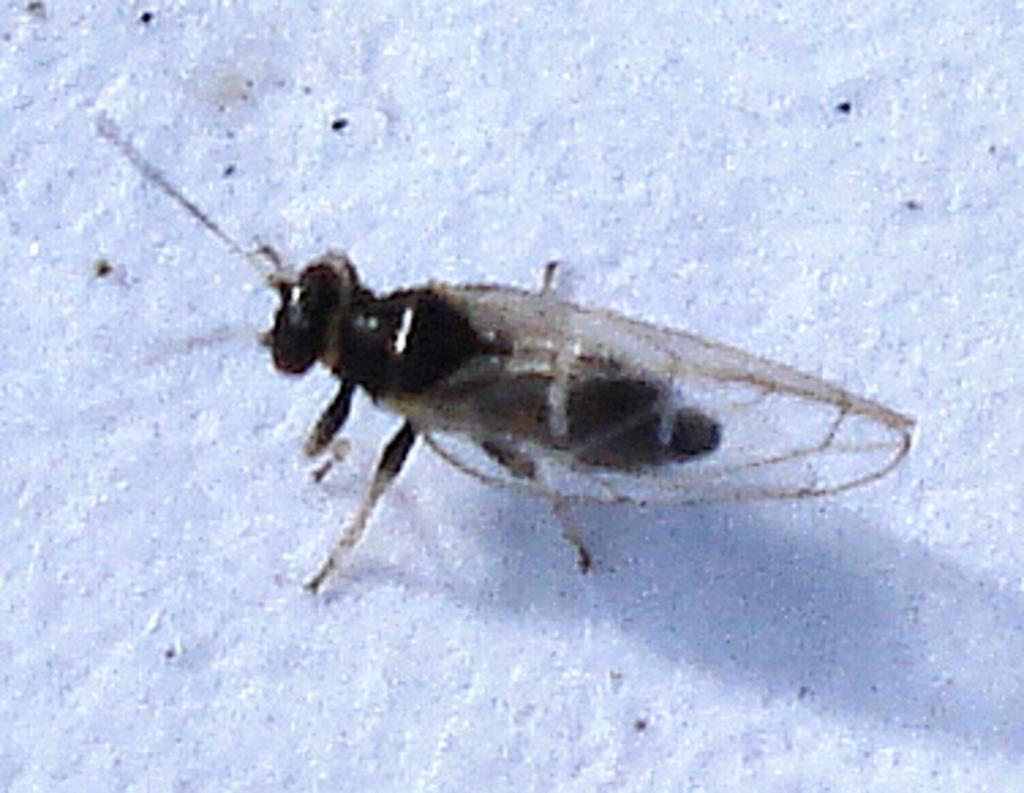What is the main subject of the image? There is a housefly in the center of the image. Can you describe the location of the housefly in the image? The housefly is in the center of the image. What type of card is the housefly holding in the image? There is no card present in the image, as it features a housefly in the center. 